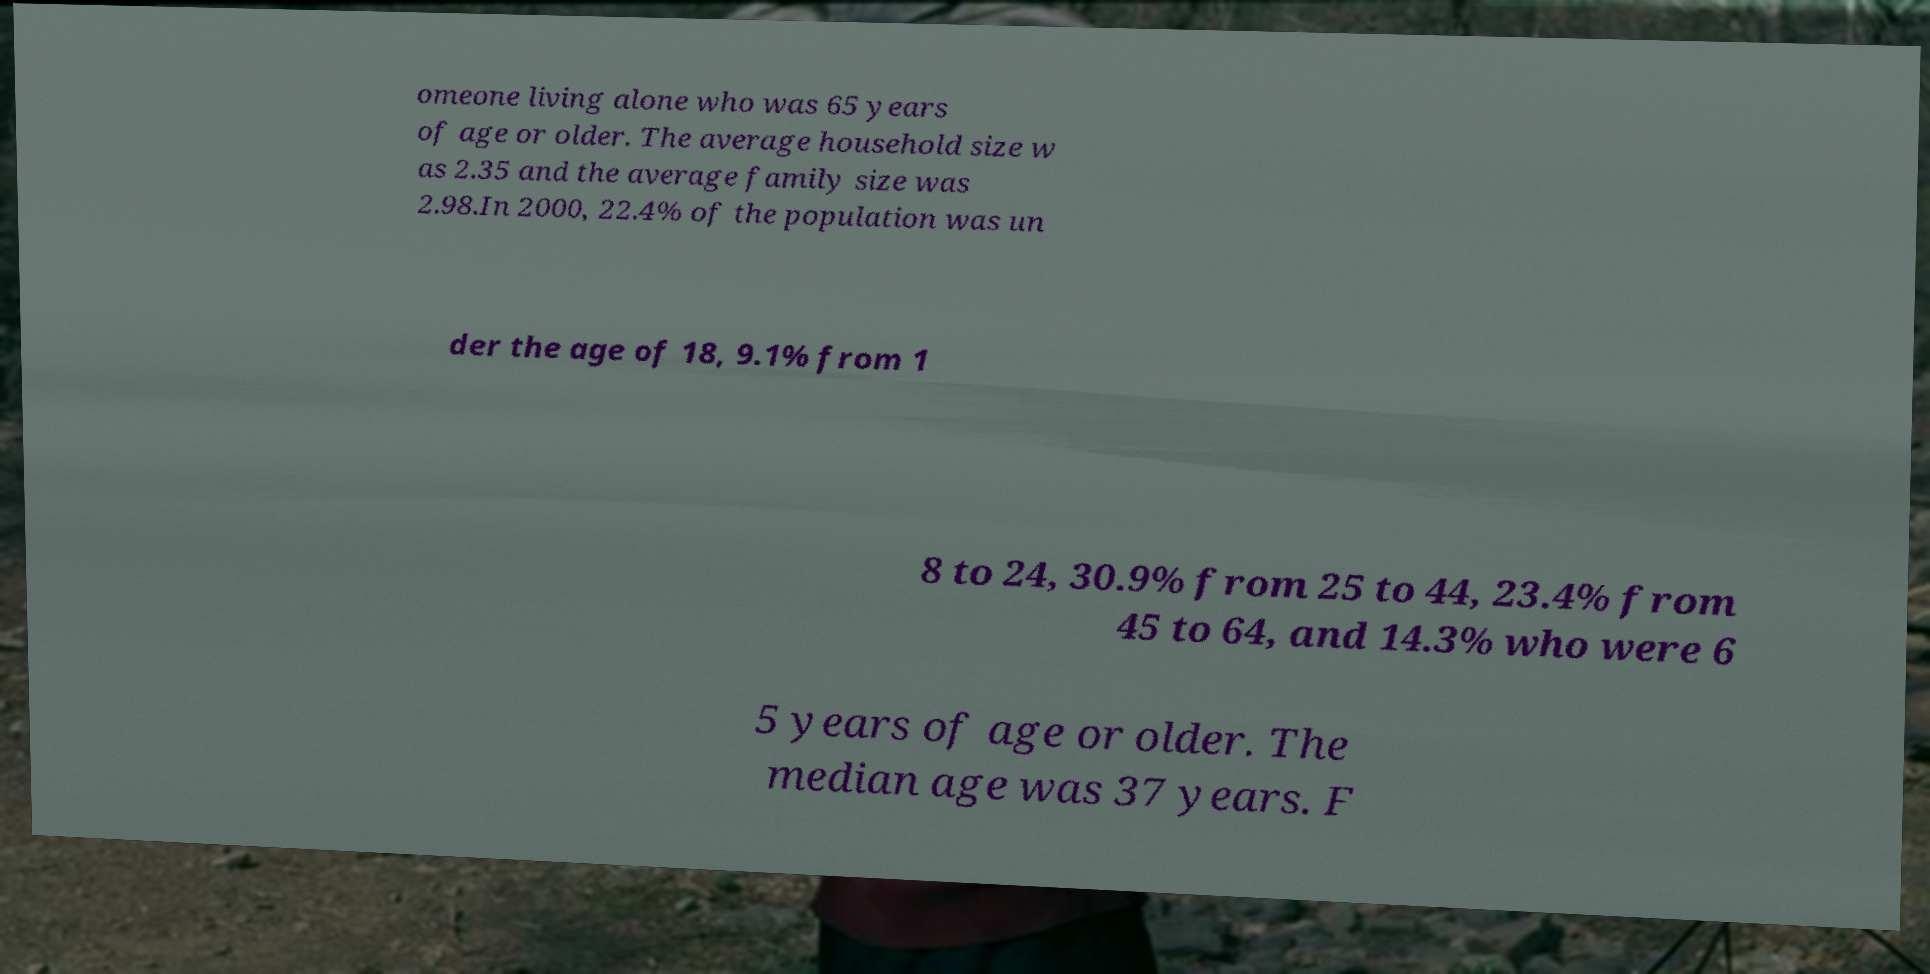Please read and relay the text visible in this image. What does it say? omeone living alone who was 65 years of age or older. The average household size w as 2.35 and the average family size was 2.98.In 2000, 22.4% of the population was un der the age of 18, 9.1% from 1 8 to 24, 30.9% from 25 to 44, 23.4% from 45 to 64, and 14.3% who were 6 5 years of age or older. The median age was 37 years. F 